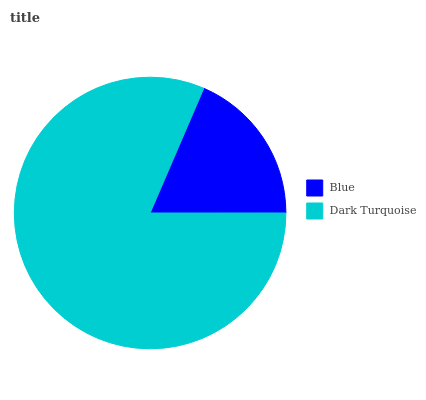Is Blue the minimum?
Answer yes or no. Yes. Is Dark Turquoise the maximum?
Answer yes or no. Yes. Is Dark Turquoise the minimum?
Answer yes or no. No. Is Dark Turquoise greater than Blue?
Answer yes or no. Yes. Is Blue less than Dark Turquoise?
Answer yes or no. Yes. Is Blue greater than Dark Turquoise?
Answer yes or no. No. Is Dark Turquoise less than Blue?
Answer yes or no. No. Is Dark Turquoise the high median?
Answer yes or no. Yes. Is Blue the low median?
Answer yes or no. Yes. Is Blue the high median?
Answer yes or no. No. Is Dark Turquoise the low median?
Answer yes or no. No. 